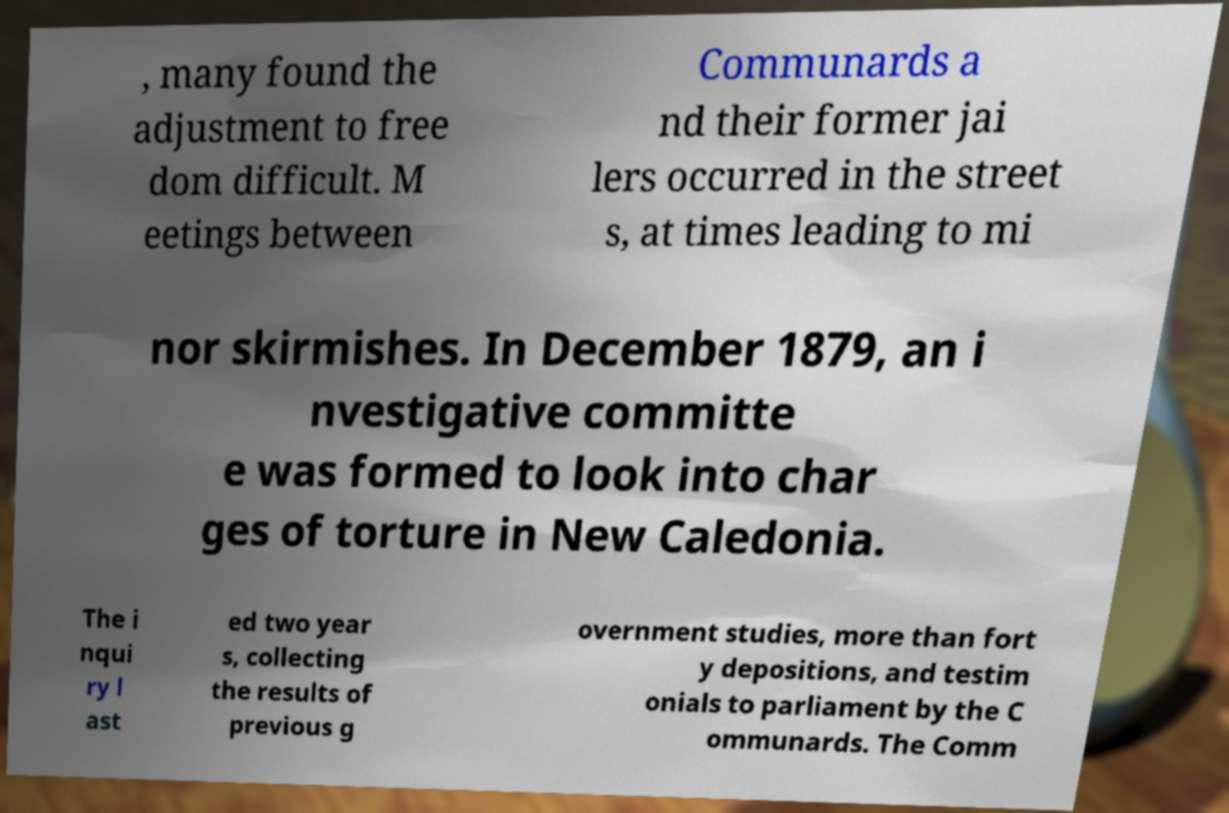Can you read and provide the text displayed in the image?This photo seems to have some interesting text. Can you extract and type it out for me? , many found the adjustment to free dom difficult. M eetings between Communards a nd their former jai lers occurred in the street s, at times leading to mi nor skirmishes. In December 1879, an i nvestigative committe e was formed to look into char ges of torture in New Caledonia. The i nqui ry l ast ed two year s, collecting the results of previous g overnment studies, more than fort y depositions, and testim onials to parliament by the C ommunards. The Comm 